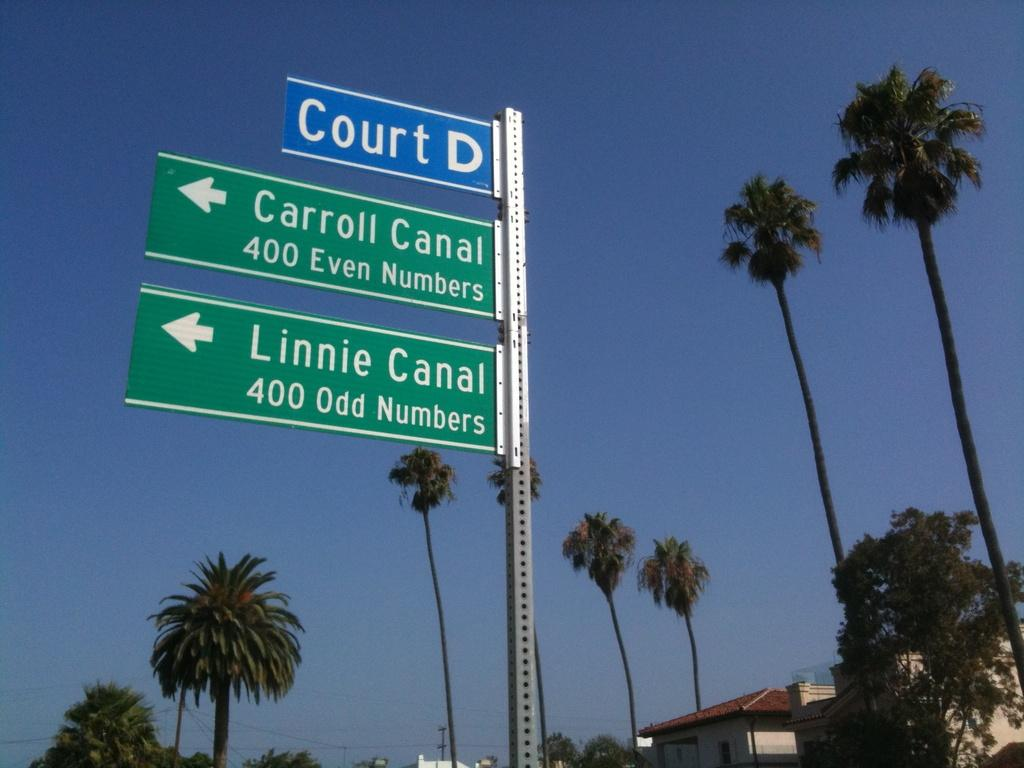What type of street naming board is present in the image? There is a blue and green color street naming board on a pole in the image. What type of vegetation can be seen in the image? Coconut trees are visible in the image. What type of structure is present in the background of the image? There is a house in the background of the image. What type of roofing material is present in the image? Roof tiles are present in the image. What type of gold jewelry is the person wearing in the image? There is no person present in the image, and therefore no jewelry can be observed. 